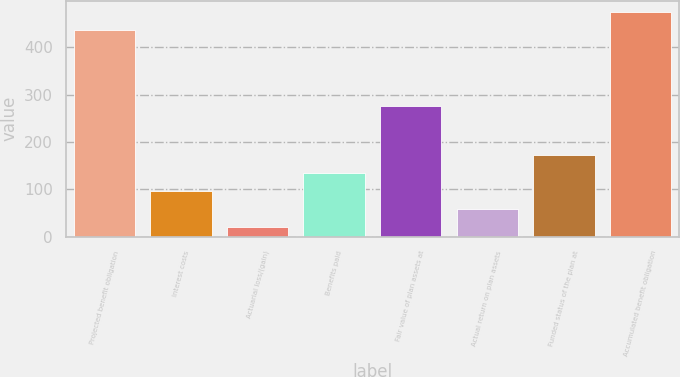<chart> <loc_0><loc_0><loc_500><loc_500><bar_chart><fcel>Projected benefit obligation<fcel>Interest costs<fcel>Actuarial loss/(gain)<fcel>Benefits paid<fcel>Fair value of plan assets at<fcel>Actual return on plan assets<fcel>Funded status of the plan at<fcel>Accumulated benefit obligation<nl><fcel>436.7<fcel>96.9<fcel>21.1<fcel>134.8<fcel>275.9<fcel>59<fcel>172.7<fcel>474.6<nl></chart> 